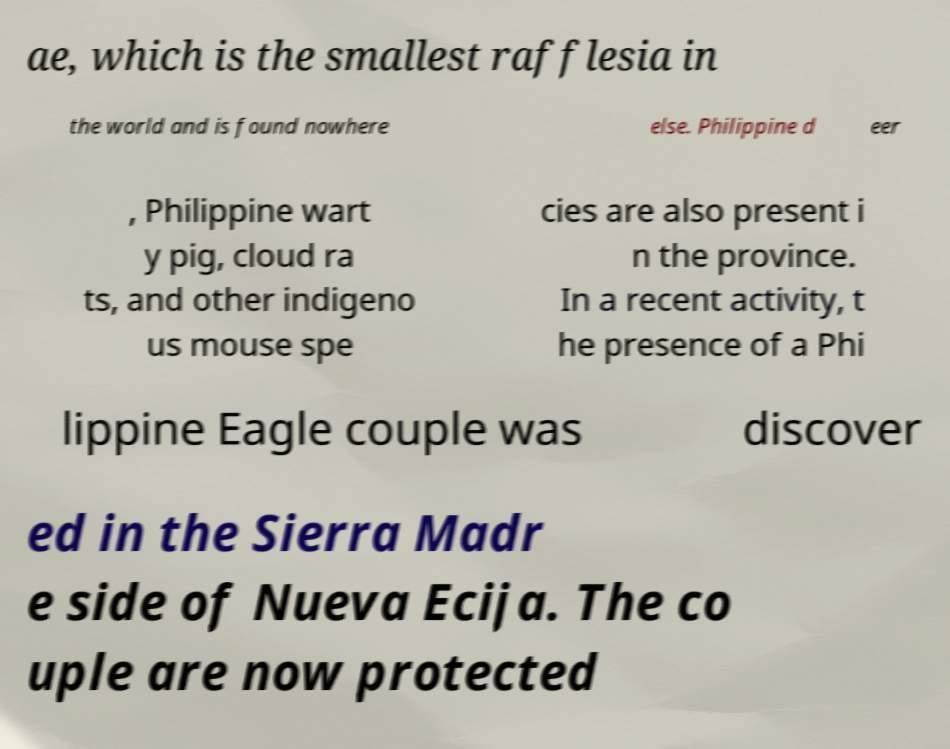Can you accurately transcribe the text from the provided image for me? ae, which is the smallest rafflesia in the world and is found nowhere else. Philippine d eer , Philippine wart y pig, cloud ra ts, and other indigeno us mouse spe cies are also present i n the province. In a recent activity, t he presence of a Phi lippine Eagle couple was discover ed in the Sierra Madr e side of Nueva Ecija. The co uple are now protected 